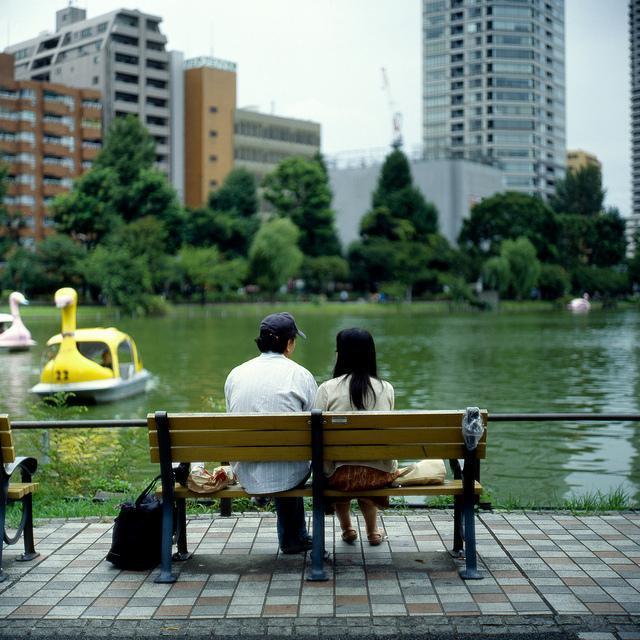How many people are sitting on the bench?
Give a very brief answer. 2. How many people are visible?
Give a very brief answer. 2. How many benches are there?
Give a very brief answer. 2. 